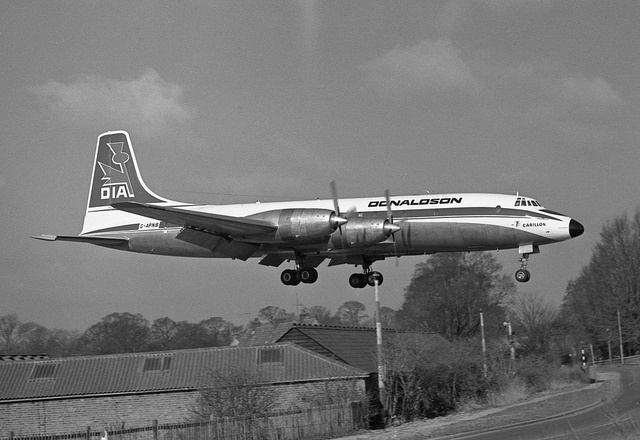Describe the objects in this image and their specific colors. I can see a airplane in gray, black, white, and darkgray tones in this image. 